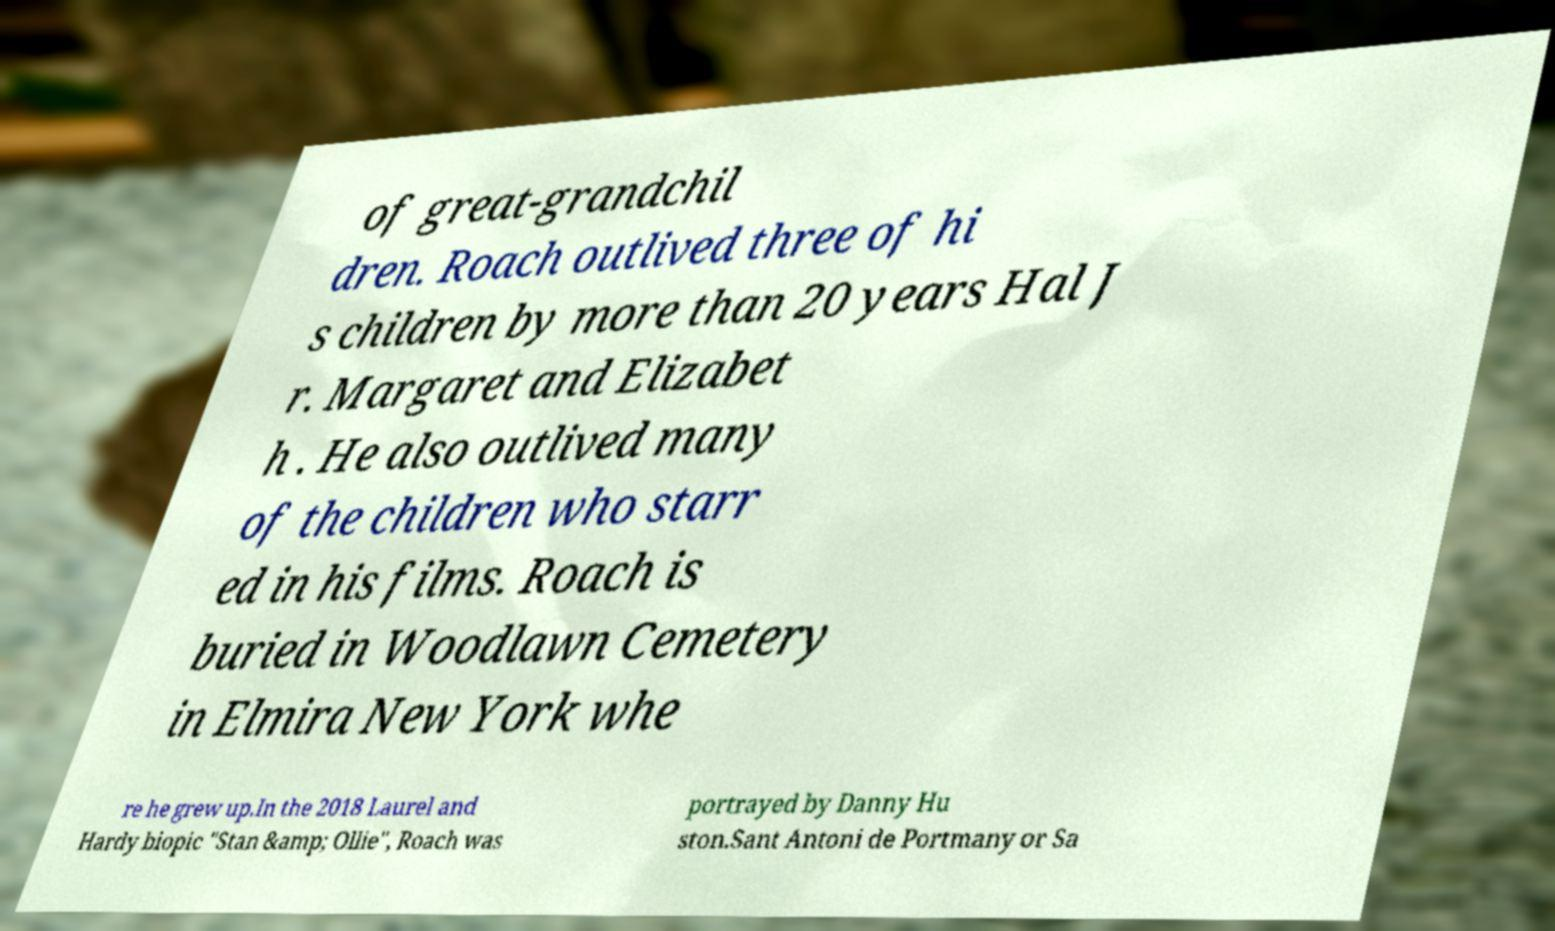Please read and relay the text visible in this image. What does it say? of great-grandchil dren. Roach outlived three of hi s children by more than 20 years Hal J r. Margaret and Elizabet h . He also outlived many of the children who starr ed in his films. Roach is buried in Woodlawn Cemetery in Elmira New York whe re he grew up.In the 2018 Laurel and Hardy biopic "Stan &amp; Ollie", Roach was portrayed by Danny Hu ston.Sant Antoni de Portmany or Sa 